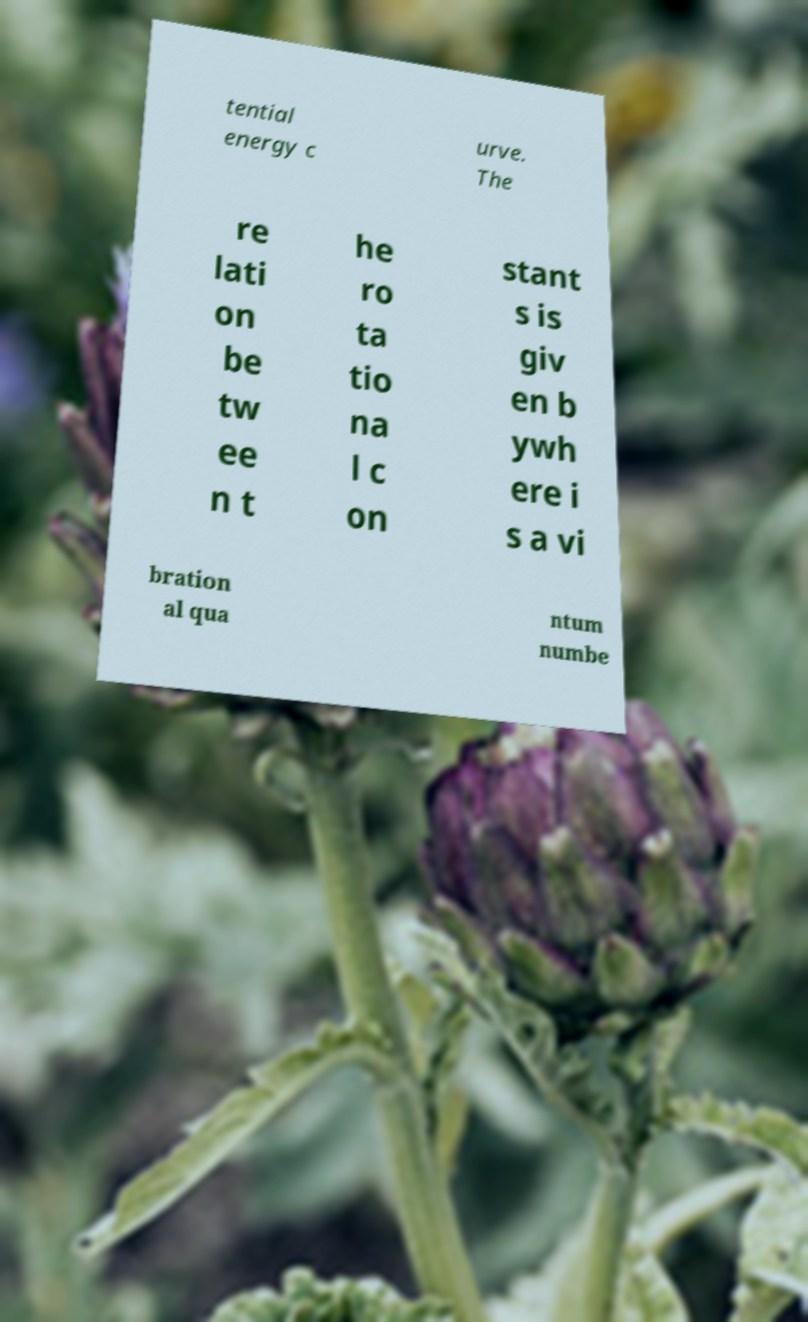Please identify and transcribe the text found in this image. tential energy c urve. The re lati on be tw ee n t he ro ta tio na l c on stant s is giv en b ywh ere i s a vi bration al qua ntum numbe 